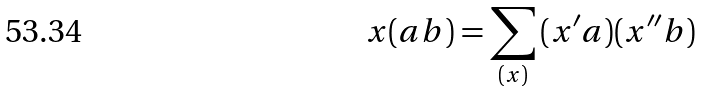<formula> <loc_0><loc_0><loc_500><loc_500>x ( a b ) = \sum _ { ( x ) } \, ( x ^ { \prime } a ) ( x ^ { \prime \prime } b )</formula> 